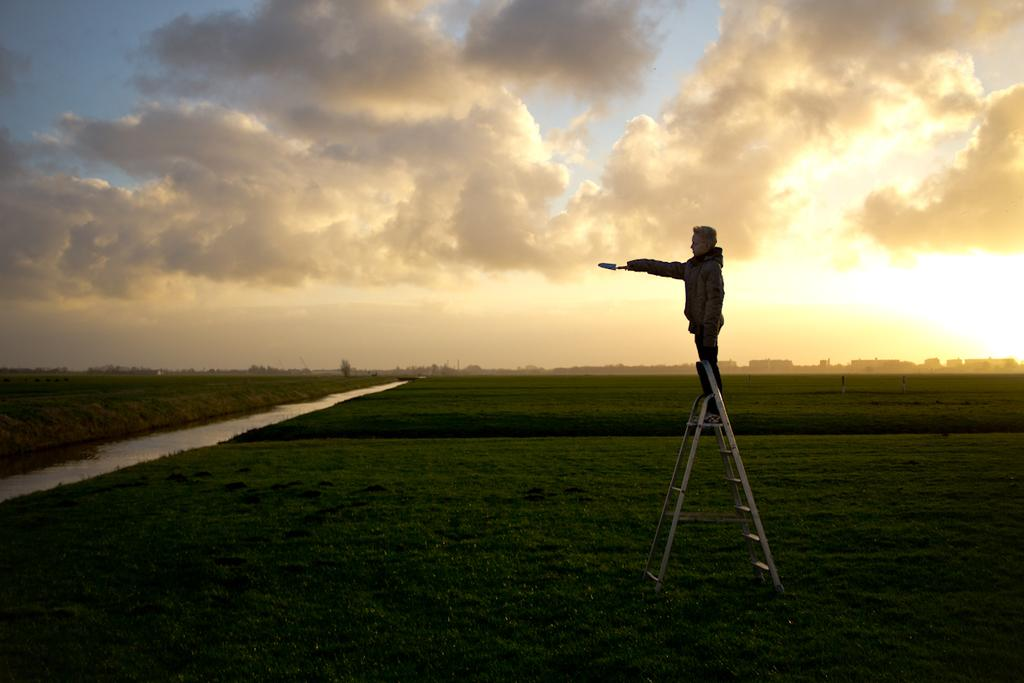What is the man in the image doing? The man is standing on a ladder. What is at the bottom of the image? There is grass at the bottom of the image. What can be seen to the left of the image? There is water to the left of the image. What is visible in the sky at the top of the image? There are clouds in the sky at the top of the image. What type of scissors is the man using to trim the grass in the image? There are no scissors present in the image, and the man is not trimming the grass. 